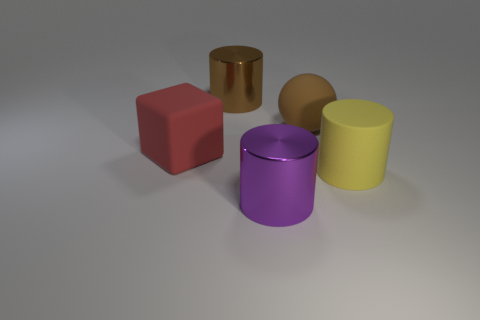Are there an equal number of big red blocks that are in front of the big yellow rubber cylinder and large brown spheres?
Your answer should be very brief. No. What number of other things are the same color as the large sphere?
Your response must be concise. 1. Are there fewer large spheres to the right of the sphere than yellow things?
Keep it short and to the point. Yes. Are there any cyan cylinders of the same size as the purple shiny thing?
Offer a terse response. No. There is a large rubber sphere; does it have the same color as the large metal object that is behind the large brown ball?
Your answer should be very brief. Yes. There is a brown object behind the large sphere; how many large matte things are to the right of it?
Your response must be concise. 2. The big rubber thing that is to the left of the cylinder in front of the yellow matte cylinder is what color?
Your answer should be very brief. Red. There is a large cylinder that is both in front of the big matte cube and on the left side of the large yellow cylinder; what is its material?
Your response must be concise. Metal. Are there any gray metallic things that have the same shape as the big red rubber thing?
Your answer should be very brief. No. Does the brown thing that is to the left of the large purple thing have the same shape as the purple object?
Provide a short and direct response. Yes. 